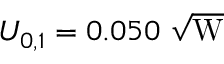Convert formula to latex. <formula><loc_0><loc_0><loc_500><loc_500>U _ { 0 , 1 } = 0 . 0 5 0 \sqrt { W }</formula> 